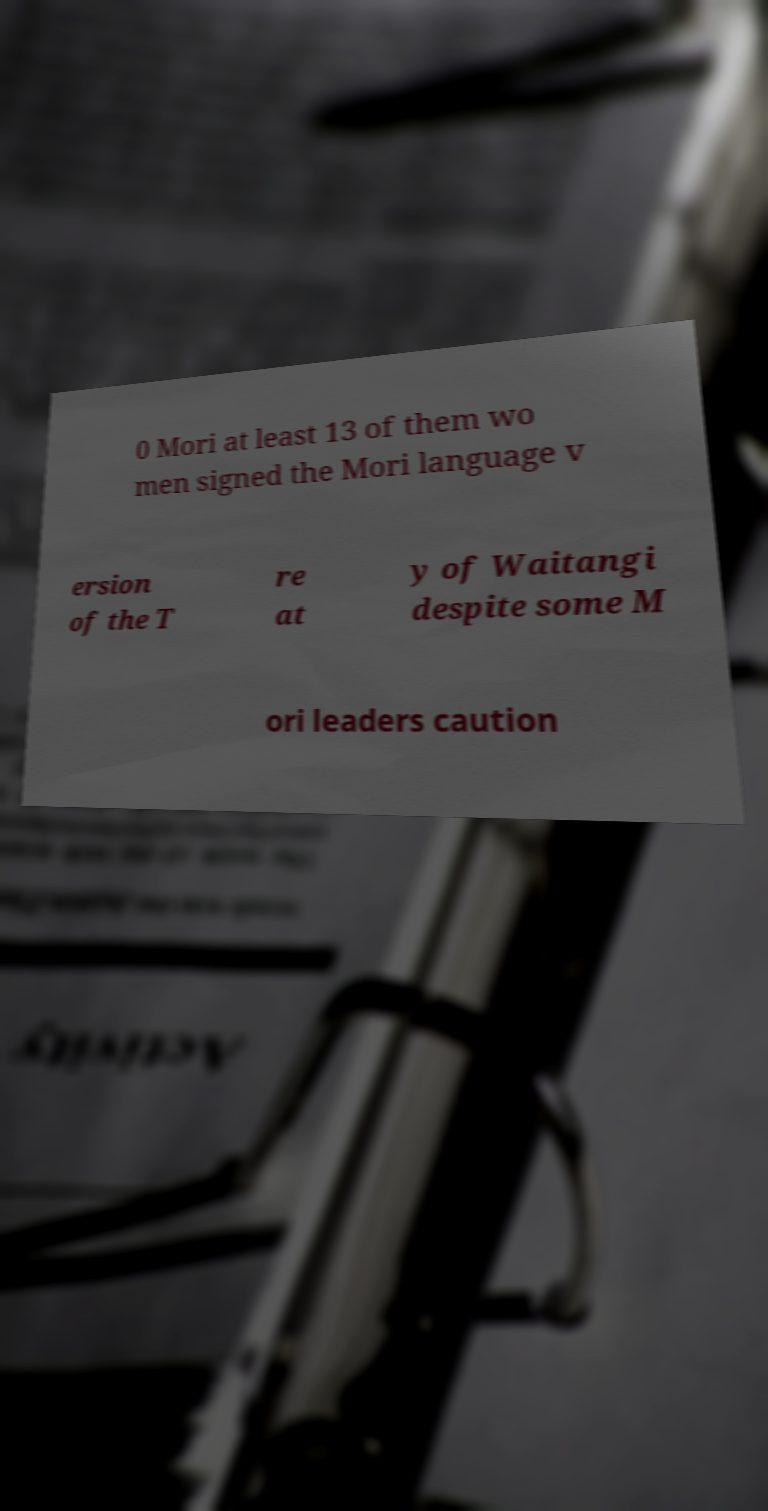Can you read and provide the text displayed in the image?This photo seems to have some interesting text. Can you extract and type it out for me? 0 Mori at least 13 of them wo men signed the Mori language v ersion of the T re at y of Waitangi despite some M ori leaders caution 